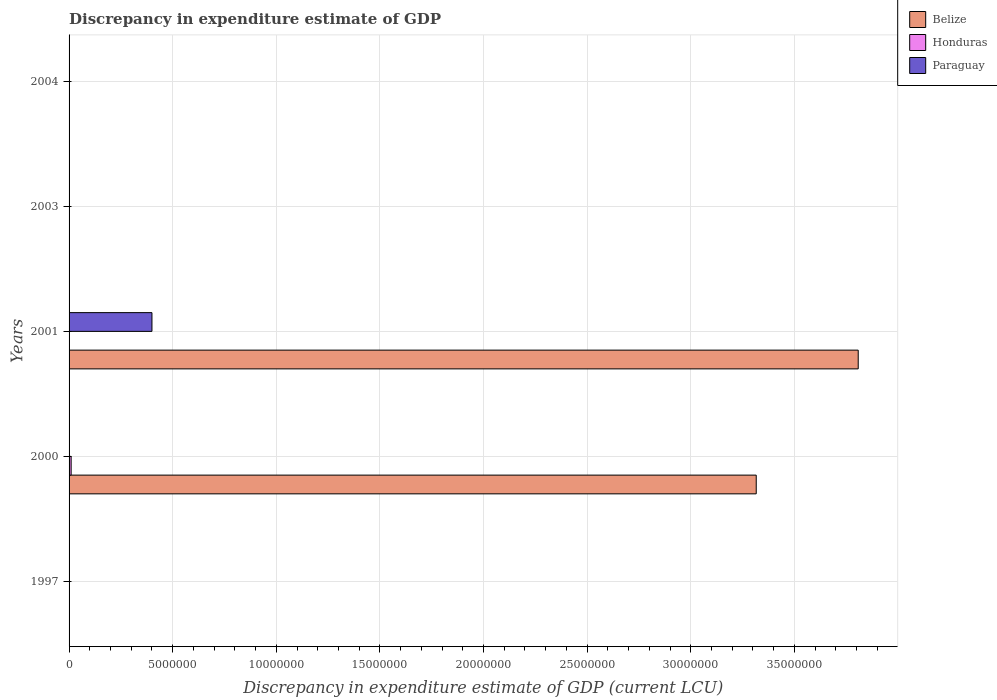How many different coloured bars are there?
Provide a short and direct response. 3. How many bars are there on the 1st tick from the bottom?
Offer a terse response. 1. In how many cases, is the number of bars for a given year not equal to the number of legend labels?
Keep it short and to the point. 4. What is the discrepancy in expenditure estimate of GDP in Belize in 2004?
Your response must be concise. 0. Across all years, what is the maximum discrepancy in expenditure estimate of GDP in Honduras?
Your answer should be very brief. 1.00e+05. What is the total discrepancy in expenditure estimate of GDP in Honduras in the graph?
Provide a short and direct response. 1.00e+05. What is the difference between the discrepancy in expenditure estimate of GDP in Belize in 2000 and that in 2001?
Your answer should be very brief. -4.92e+06. What is the average discrepancy in expenditure estimate of GDP in Honduras per year?
Offer a very short reply. 2.00e+04. In the year 2000, what is the difference between the discrepancy in expenditure estimate of GDP in Belize and discrepancy in expenditure estimate of GDP in Paraguay?
Give a very brief answer. 3.32e+07. What is the difference between the highest and the lowest discrepancy in expenditure estimate of GDP in Honduras?
Your response must be concise. 1.00e+05. Is the sum of the discrepancy in expenditure estimate of GDP in Belize in 2000 and 2001 greater than the maximum discrepancy in expenditure estimate of GDP in Paraguay across all years?
Ensure brevity in your answer.  Yes. Is it the case that in every year, the sum of the discrepancy in expenditure estimate of GDP in Paraguay and discrepancy in expenditure estimate of GDP in Honduras is greater than the discrepancy in expenditure estimate of GDP in Belize?
Make the answer very short. No. Are all the bars in the graph horizontal?
Provide a succinct answer. Yes. How many years are there in the graph?
Offer a very short reply. 5. What is the difference between two consecutive major ticks on the X-axis?
Your answer should be very brief. 5.00e+06. Does the graph contain any zero values?
Your answer should be compact. Yes. Does the graph contain grids?
Give a very brief answer. Yes. Where does the legend appear in the graph?
Ensure brevity in your answer.  Top right. How many legend labels are there?
Your answer should be compact. 3. What is the title of the graph?
Offer a terse response. Discrepancy in expenditure estimate of GDP. What is the label or title of the X-axis?
Your answer should be compact. Discrepancy in expenditure estimate of GDP (current LCU). What is the label or title of the Y-axis?
Ensure brevity in your answer.  Years. What is the Discrepancy in expenditure estimate of GDP (current LCU) of Belize in 1997?
Keep it short and to the point. 0. What is the Discrepancy in expenditure estimate of GDP (current LCU) of Honduras in 1997?
Your answer should be compact. 8e-6. What is the Discrepancy in expenditure estimate of GDP (current LCU) in Paraguay in 1997?
Provide a succinct answer. 0. What is the Discrepancy in expenditure estimate of GDP (current LCU) of Belize in 2000?
Provide a short and direct response. 3.32e+07. What is the Discrepancy in expenditure estimate of GDP (current LCU) of Honduras in 2000?
Keep it short and to the point. 1.00e+05. What is the Discrepancy in expenditure estimate of GDP (current LCU) of Paraguay in 2000?
Give a very brief answer. 0. What is the Discrepancy in expenditure estimate of GDP (current LCU) in Belize in 2001?
Your response must be concise. 3.81e+07. What is the Discrepancy in expenditure estimate of GDP (current LCU) in Honduras in 2001?
Ensure brevity in your answer.  0. What is the Discrepancy in expenditure estimate of GDP (current LCU) in Paraguay in 2001?
Keep it short and to the point. 4.00e+06. What is the Discrepancy in expenditure estimate of GDP (current LCU) of Honduras in 2003?
Keep it short and to the point. 0. What is the Discrepancy in expenditure estimate of GDP (current LCU) of Honduras in 2004?
Keep it short and to the point. 0. Across all years, what is the maximum Discrepancy in expenditure estimate of GDP (current LCU) of Belize?
Provide a short and direct response. 3.81e+07. Across all years, what is the maximum Discrepancy in expenditure estimate of GDP (current LCU) of Honduras?
Provide a short and direct response. 1.00e+05. Across all years, what is the maximum Discrepancy in expenditure estimate of GDP (current LCU) of Paraguay?
Provide a short and direct response. 4.00e+06. Across all years, what is the minimum Discrepancy in expenditure estimate of GDP (current LCU) in Paraguay?
Offer a very short reply. 0. What is the total Discrepancy in expenditure estimate of GDP (current LCU) in Belize in the graph?
Provide a succinct answer. 7.12e+07. What is the total Discrepancy in expenditure estimate of GDP (current LCU) in Honduras in the graph?
Offer a terse response. 1.00e+05. What is the total Discrepancy in expenditure estimate of GDP (current LCU) of Paraguay in the graph?
Give a very brief answer. 4.00e+06. What is the difference between the Discrepancy in expenditure estimate of GDP (current LCU) of Belize in 2000 and that in 2001?
Give a very brief answer. -4.92e+06. What is the difference between the Discrepancy in expenditure estimate of GDP (current LCU) in Paraguay in 2000 and that in 2001?
Make the answer very short. -4.00e+06. What is the difference between the Discrepancy in expenditure estimate of GDP (current LCU) of Honduras in 1997 and the Discrepancy in expenditure estimate of GDP (current LCU) of Paraguay in 2000?
Provide a short and direct response. -0. What is the difference between the Discrepancy in expenditure estimate of GDP (current LCU) of Honduras in 1997 and the Discrepancy in expenditure estimate of GDP (current LCU) of Paraguay in 2001?
Keep it short and to the point. -4.00e+06. What is the difference between the Discrepancy in expenditure estimate of GDP (current LCU) of Belize in 2000 and the Discrepancy in expenditure estimate of GDP (current LCU) of Paraguay in 2001?
Offer a terse response. 2.92e+07. What is the difference between the Discrepancy in expenditure estimate of GDP (current LCU) in Honduras in 2000 and the Discrepancy in expenditure estimate of GDP (current LCU) in Paraguay in 2001?
Provide a short and direct response. -3.90e+06. What is the average Discrepancy in expenditure estimate of GDP (current LCU) in Belize per year?
Your answer should be very brief. 1.42e+07. What is the average Discrepancy in expenditure estimate of GDP (current LCU) in Paraguay per year?
Keep it short and to the point. 8.00e+05. In the year 2000, what is the difference between the Discrepancy in expenditure estimate of GDP (current LCU) of Belize and Discrepancy in expenditure estimate of GDP (current LCU) of Honduras?
Your answer should be compact. 3.31e+07. In the year 2000, what is the difference between the Discrepancy in expenditure estimate of GDP (current LCU) in Belize and Discrepancy in expenditure estimate of GDP (current LCU) in Paraguay?
Keep it short and to the point. 3.32e+07. In the year 2000, what is the difference between the Discrepancy in expenditure estimate of GDP (current LCU) in Honduras and Discrepancy in expenditure estimate of GDP (current LCU) in Paraguay?
Offer a very short reply. 1.00e+05. In the year 2001, what is the difference between the Discrepancy in expenditure estimate of GDP (current LCU) in Belize and Discrepancy in expenditure estimate of GDP (current LCU) in Paraguay?
Your answer should be very brief. 3.41e+07. What is the ratio of the Discrepancy in expenditure estimate of GDP (current LCU) of Belize in 2000 to that in 2001?
Offer a terse response. 0.87. What is the difference between the highest and the lowest Discrepancy in expenditure estimate of GDP (current LCU) of Belize?
Your response must be concise. 3.81e+07. What is the difference between the highest and the lowest Discrepancy in expenditure estimate of GDP (current LCU) in Paraguay?
Give a very brief answer. 4.00e+06. 